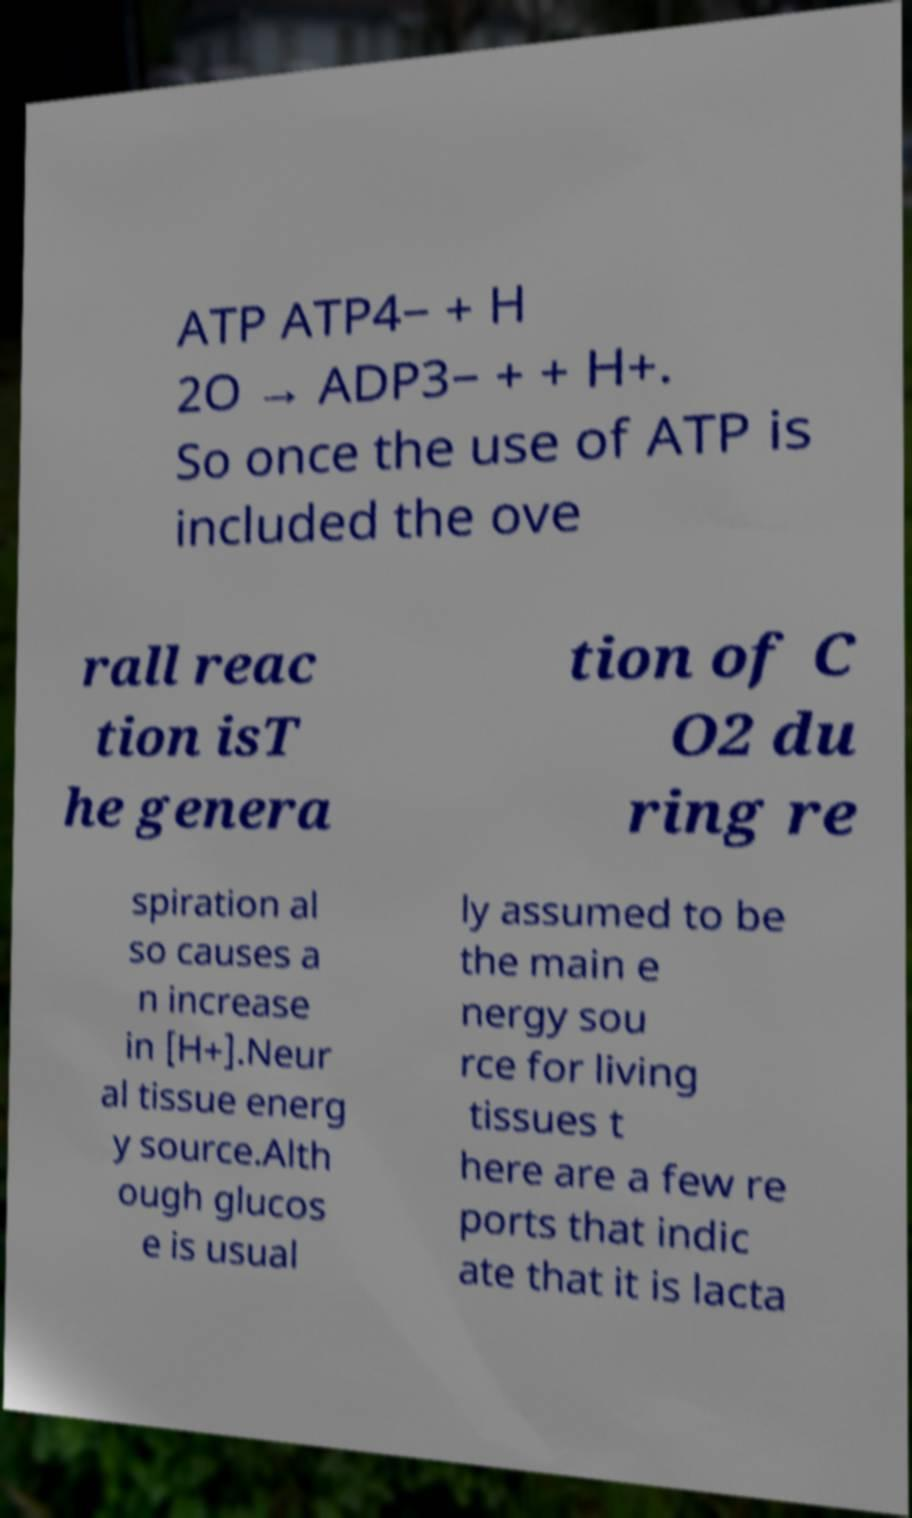Could you extract and type out the text from this image? ATP ATP4− + H 2O → ADP3− + + H+. So once the use of ATP is included the ove rall reac tion isT he genera tion of C O2 du ring re spiration al so causes a n increase in [H+].Neur al tissue energ y source.Alth ough glucos e is usual ly assumed to be the main e nergy sou rce for living tissues t here are a few re ports that indic ate that it is lacta 